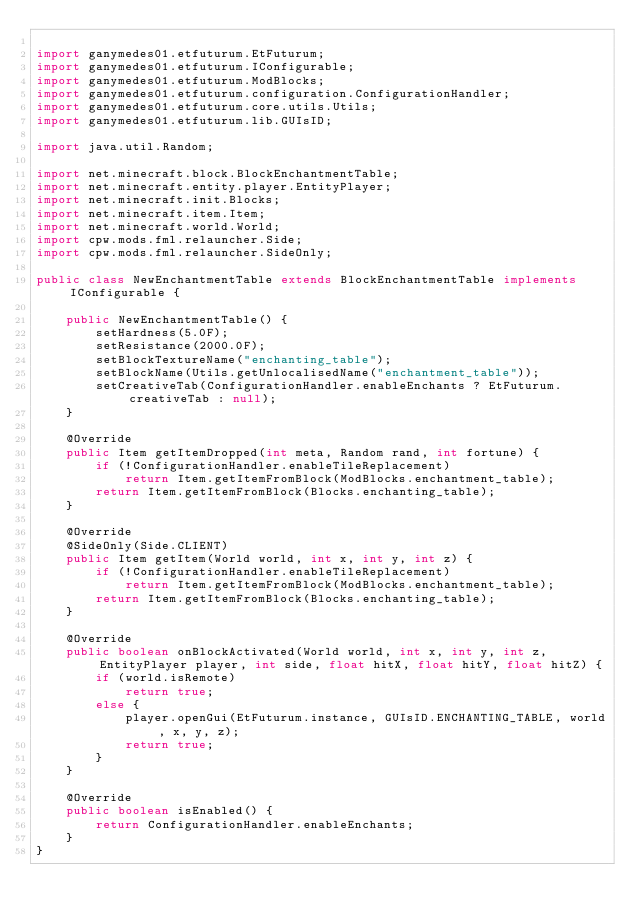<code> <loc_0><loc_0><loc_500><loc_500><_Java_>
import ganymedes01.etfuturum.EtFuturum;
import ganymedes01.etfuturum.IConfigurable;
import ganymedes01.etfuturum.ModBlocks;
import ganymedes01.etfuturum.configuration.ConfigurationHandler;
import ganymedes01.etfuturum.core.utils.Utils;
import ganymedes01.etfuturum.lib.GUIsID;

import java.util.Random;

import net.minecraft.block.BlockEnchantmentTable;
import net.minecraft.entity.player.EntityPlayer;
import net.minecraft.init.Blocks;
import net.minecraft.item.Item;
import net.minecraft.world.World;
import cpw.mods.fml.relauncher.Side;
import cpw.mods.fml.relauncher.SideOnly;

public class NewEnchantmentTable extends BlockEnchantmentTable implements IConfigurable {

	public NewEnchantmentTable() {
		setHardness(5.0F);
		setResistance(2000.0F);
		setBlockTextureName("enchanting_table");
		setBlockName(Utils.getUnlocalisedName("enchantment_table"));
		setCreativeTab(ConfigurationHandler.enableEnchants ? EtFuturum.creativeTab : null);
	}

	@Override
	public Item getItemDropped(int meta, Random rand, int fortune) {
		if (!ConfigurationHandler.enableTileReplacement)
			return Item.getItemFromBlock(ModBlocks.enchantment_table);
		return Item.getItemFromBlock(Blocks.enchanting_table);
	}

	@Override
	@SideOnly(Side.CLIENT)
	public Item getItem(World world, int x, int y, int z) {
		if (!ConfigurationHandler.enableTileReplacement)
			return Item.getItemFromBlock(ModBlocks.enchantment_table);
		return Item.getItemFromBlock(Blocks.enchanting_table);
	}

	@Override
	public boolean onBlockActivated(World world, int x, int y, int z, EntityPlayer player, int side, float hitX, float hitY, float hitZ) {
		if (world.isRemote)
			return true;
		else {
			player.openGui(EtFuturum.instance, GUIsID.ENCHANTING_TABLE, world, x, y, z);
			return true;
		}
	}

	@Override
	public boolean isEnabled() {
		return ConfigurationHandler.enableEnchants;
	}
}</code> 